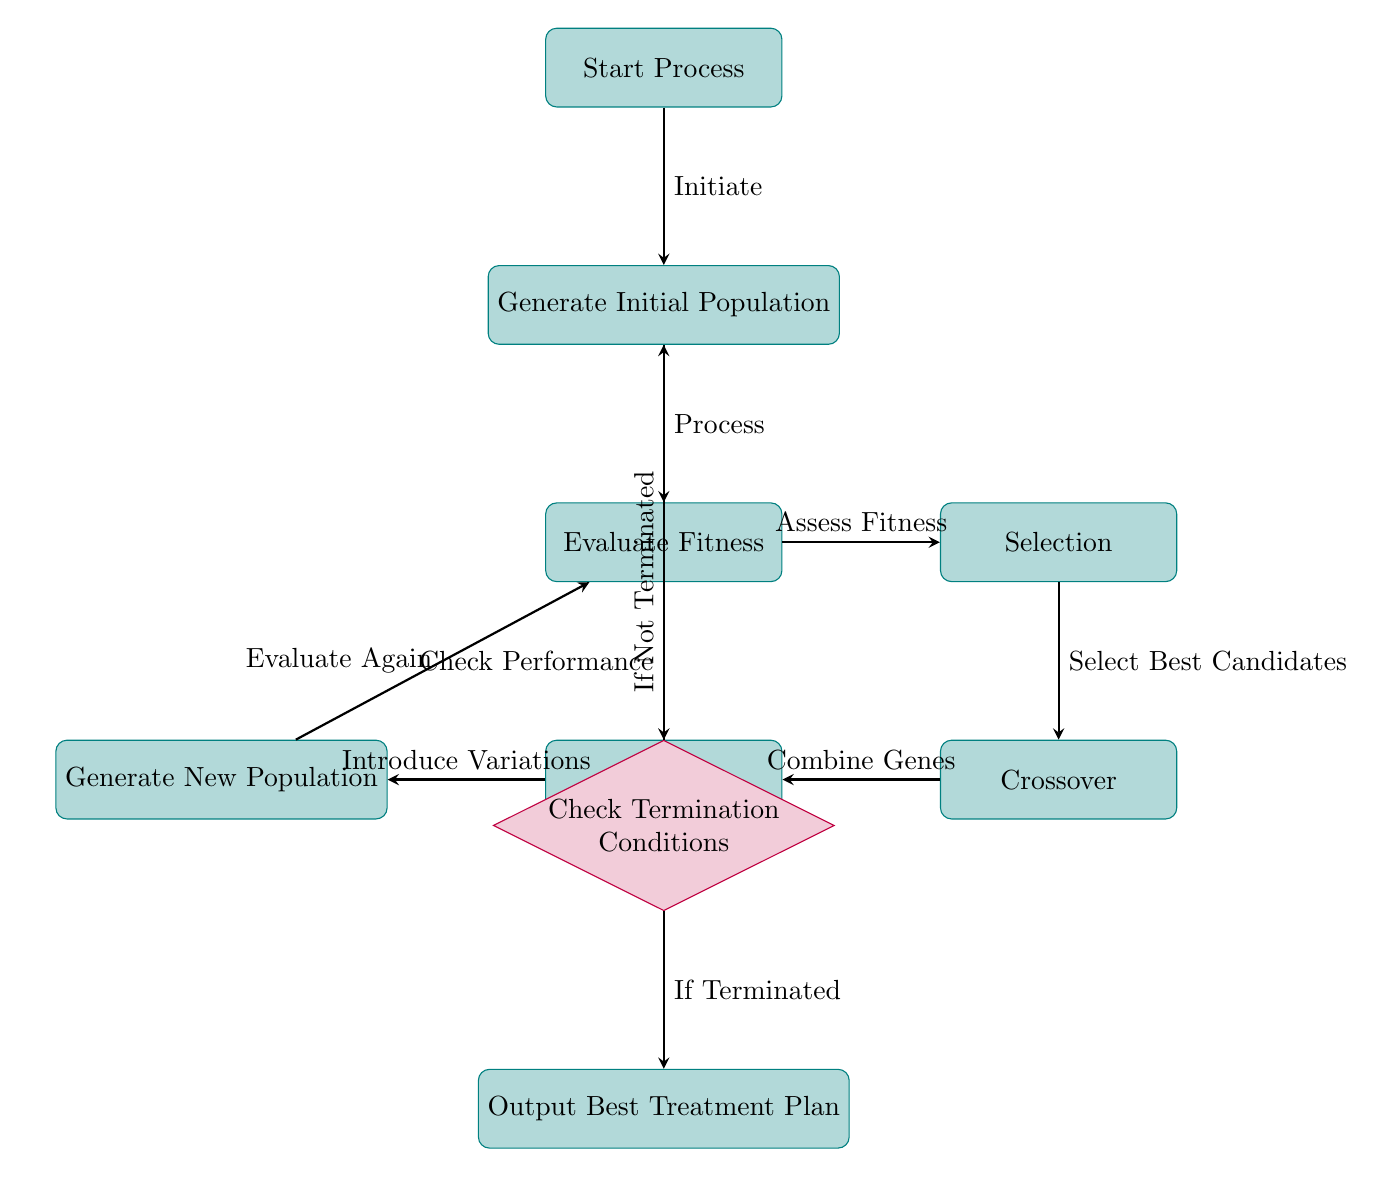What is the first step in the genetic algorithm flow? The diagram indicates that the first step in the genetic algorithm flow is the "Start Process" node. This step initiates the entire process of applying genetic algorithms in personalized medicine.
Answer: Start Process How many nodes are there in the diagram? By counting all the labeled rectangular and diamond-shaped nodes in the diagram, we find that there are a total of 8 nodes representing various processes and decisions.
Answer: 8 What follows after assessing fitness? After evaluating fitness in the diagram, the next step is "Selection", where the best candidates are selected based on their fitness scores for further processing.
Answer: Selection What happens if termination conditions are not met? According to the diagram, if the termination conditions are not met, the algorithm loops back to the "Generate Initial Population" node, indicating a continuation of the process.
Answer: Generate Initial Population Which node is responsible for combining genes? The "Crossover" node is directly responsible for combining genes, signifying the genetic operation where selected genes from parent solutions are combined to create new offspring.
Answer: Crossover What does the mutation step introduce? The mutation step introduces variations to the population, which is essential for maintaining diversity and preventing premature convergence in the genetic algorithm.
Answer: Variations What is the output of the genetic algorithm flow? The diagram indicates that the final output of the genetic algorithm process is the "Output Best Treatment Plan," representing the culmination of the personalized medicine approach.
Answer: Output Best Treatment Plan What connects the mutation and new population nodes? An arrow is drawn connecting the "Mutation" node to the "Generate New Population" node, indicating a direct flow resulting from introducing variations.
Answer: Evaluate Again What action is taken after fitness evaluation? Following the evaluation of fitness, the action taken is to select the best candidates based on the assessment, leading into the next stage of the process.
Answer: Select Best Candidates 